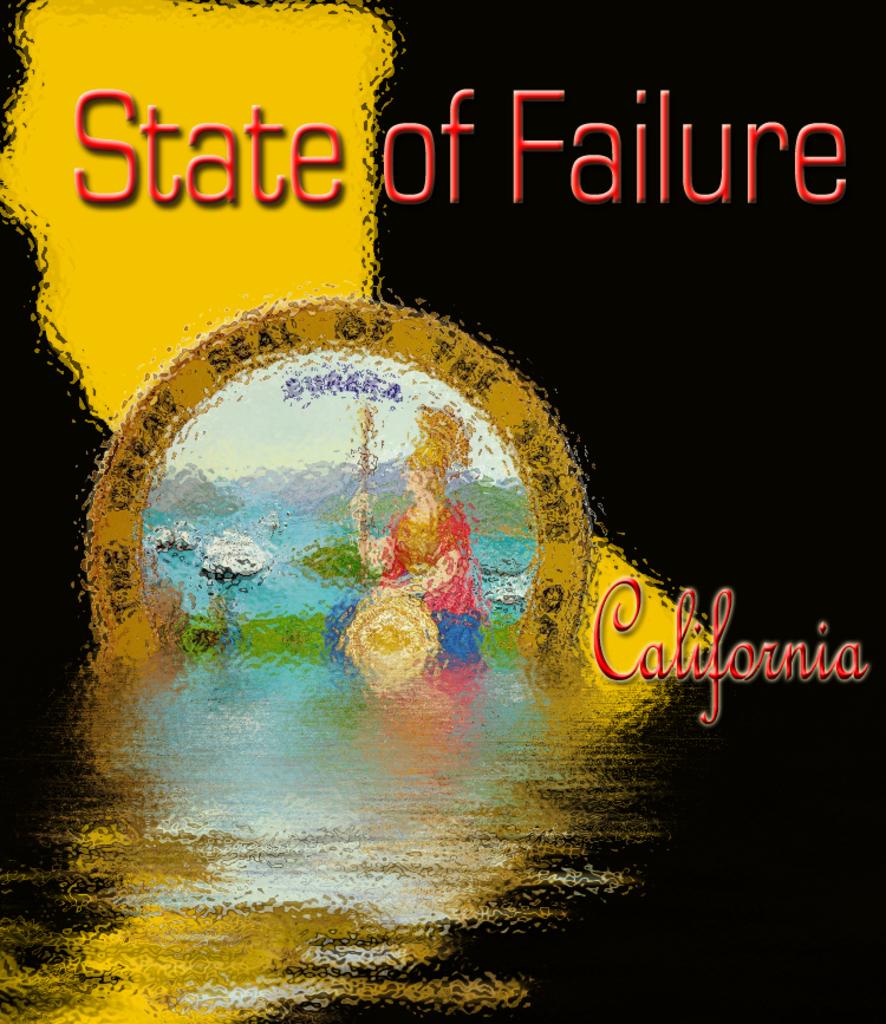What state of failure is this?
Provide a short and direct response. California. 